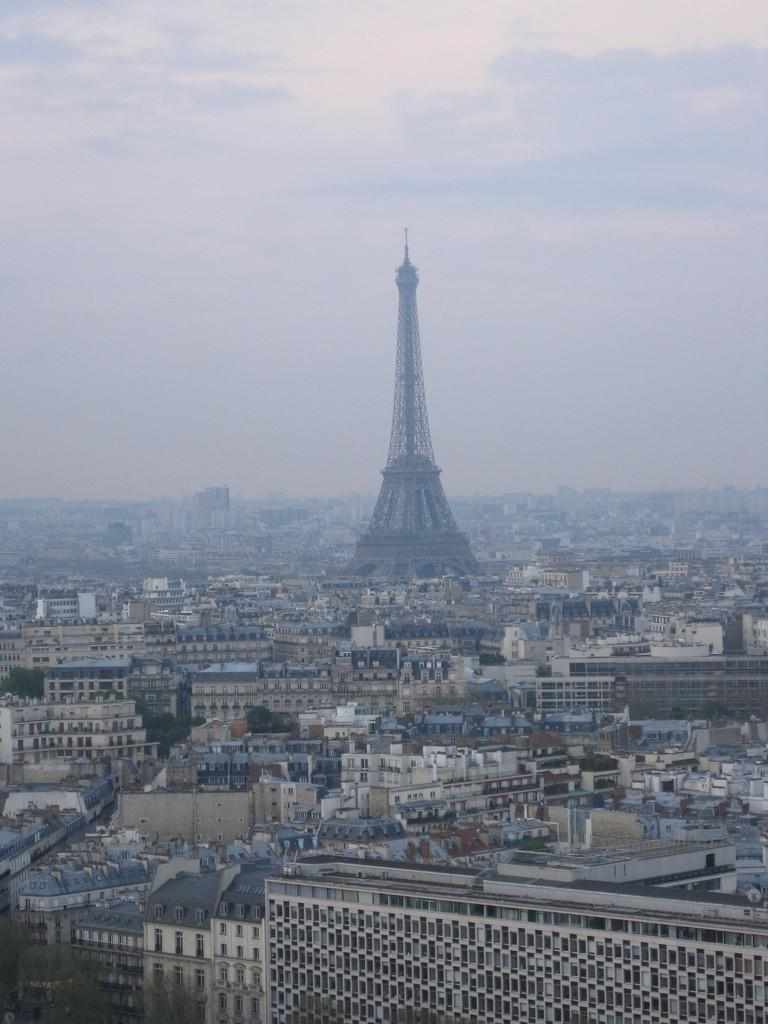What is the main subject of the image? The main subject of the image is an overview of a city. What types of structures can be seen in the image? There are buildings and a tower visible in the image. What can be seen in the background of the image? The sky is visible in the background of the image. How many goats are visible in the image? There are no goats present in the image. What type of cats can be seen interacting with the buildings in the image? There are no cats present in the image. 